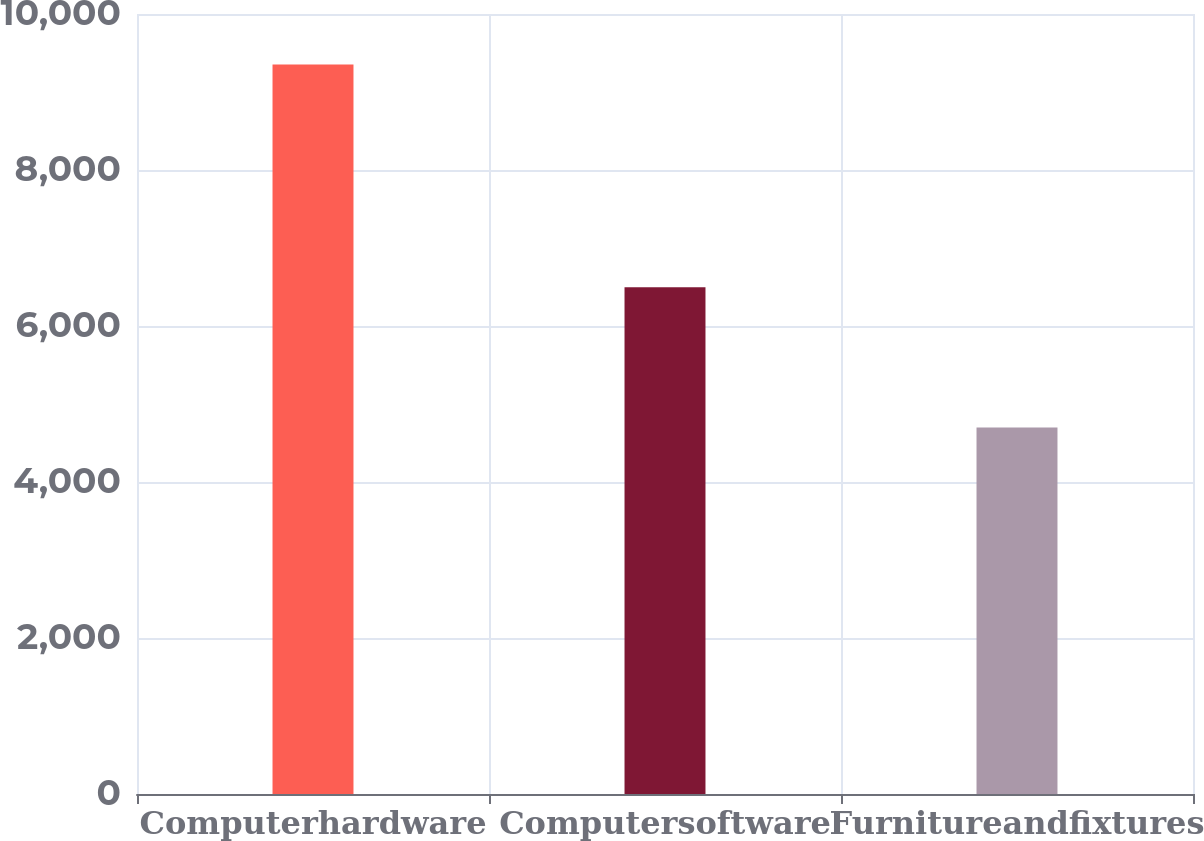Convert chart to OTSL. <chart><loc_0><loc_0><loc_500><loc_500><bar_chart><fcel>Computerhardware<fcel>Computersoftware<fcel>Furnitureandfixtures<nl><fcel>9352<fcel>6498<fcel>4698<nl></chart> 